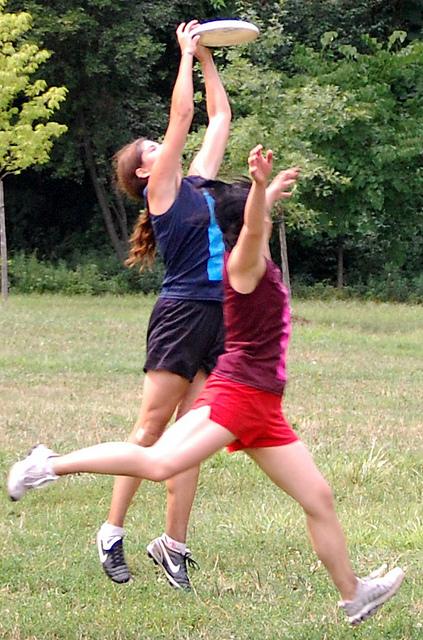Is anyone wearing nike tennis shoes?
Write a very short answer. Yes. What color shorts is the person in front wearing?
Be succinct. Red. What game are they playing?
Give a very brief answer. Frisbee. 